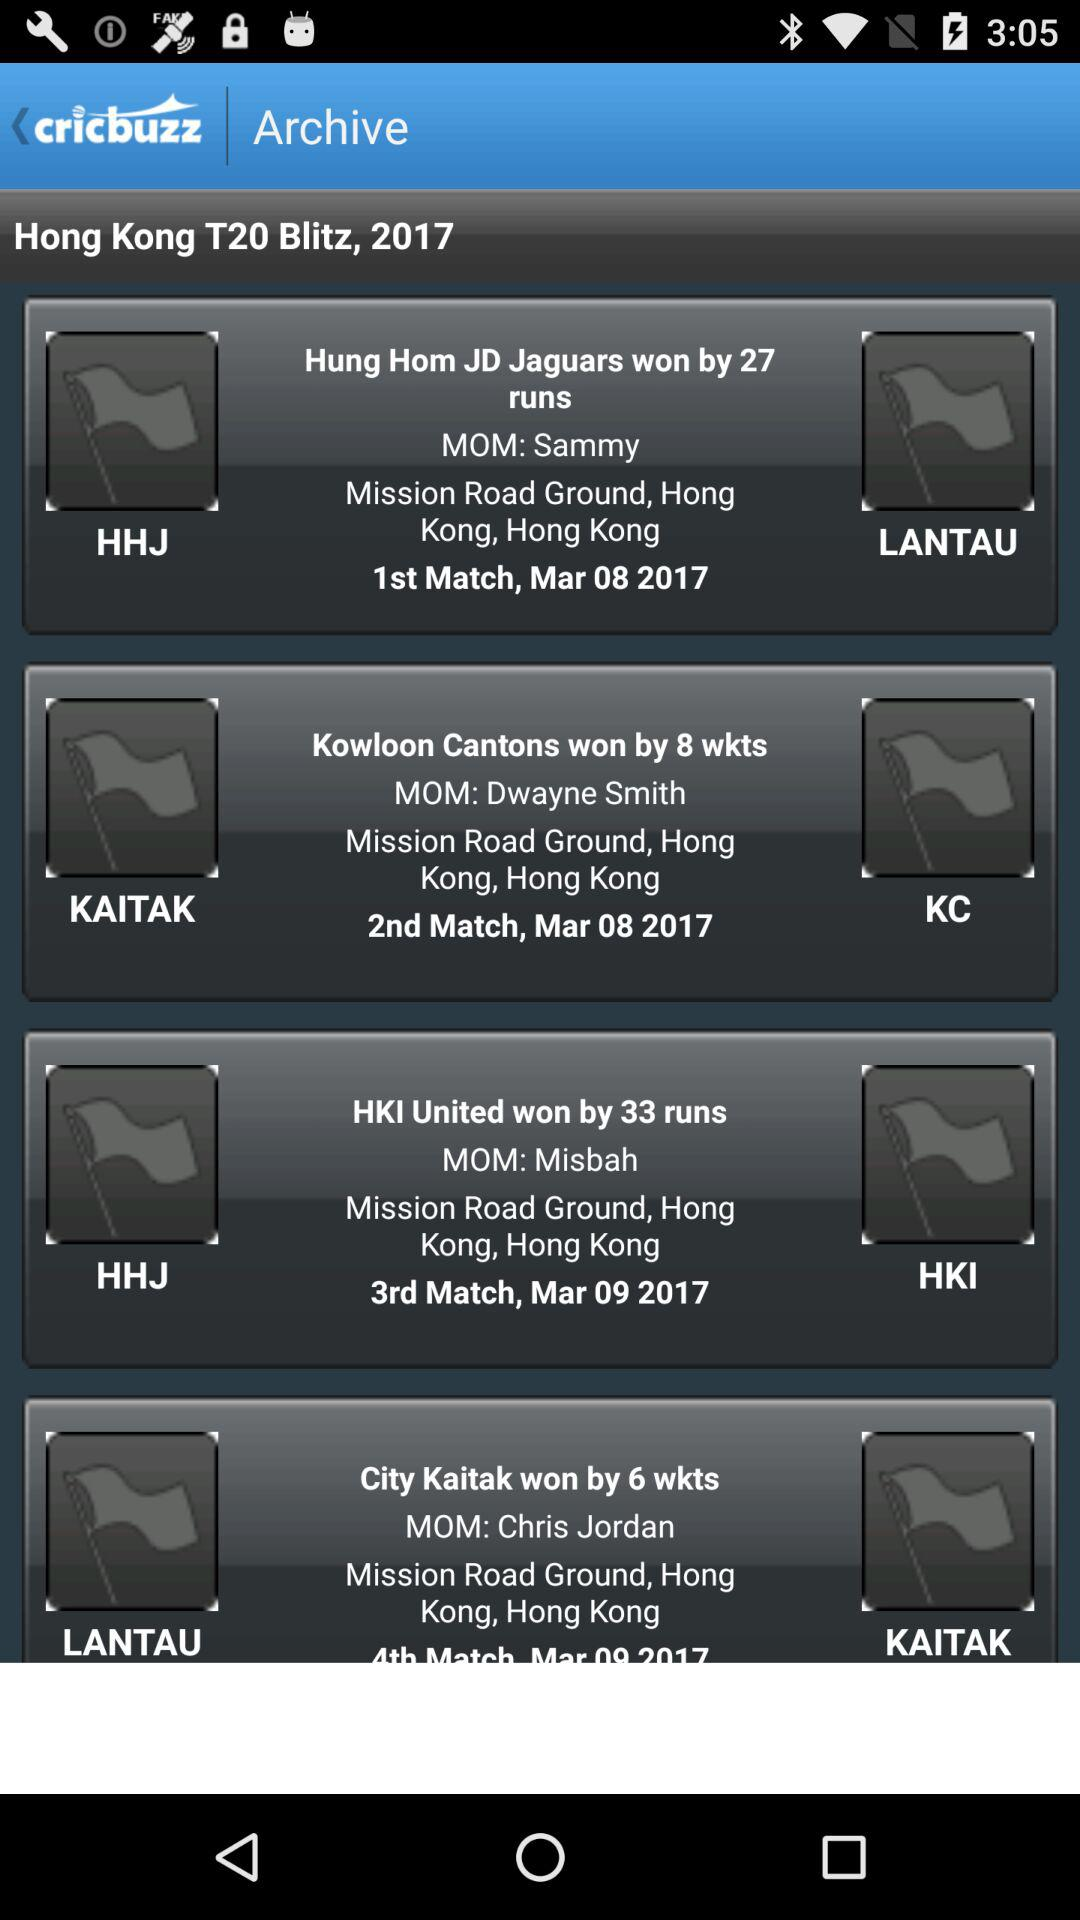When did the first match happen? The first match was on March 8, 2017. 